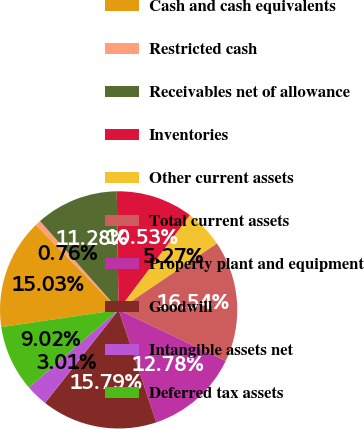Convert chart. <chart><loc_0><loc_0><loc_500><loc_500><pie_chart><fcel>Cash and cash equivalents<fcel>Restricted cash<fcel>Receivables net of allowance<fcel>Inventories<fcel>Other current assets<fcel>Total current assets<fcel>Property plant and equipment<fcel>Goodwill<fcel>Intangible assets net<fcel>Deferred tax assets<nl><fcel>15.03%<fcel>0.76%<fcel>11.28%<fcel>10.53%<fcel>5.27%<fcel>16.54%<fcel>12.78%<fcel>15.79%<fcel>3.01%<fcel>9.02%<nl></chart> 